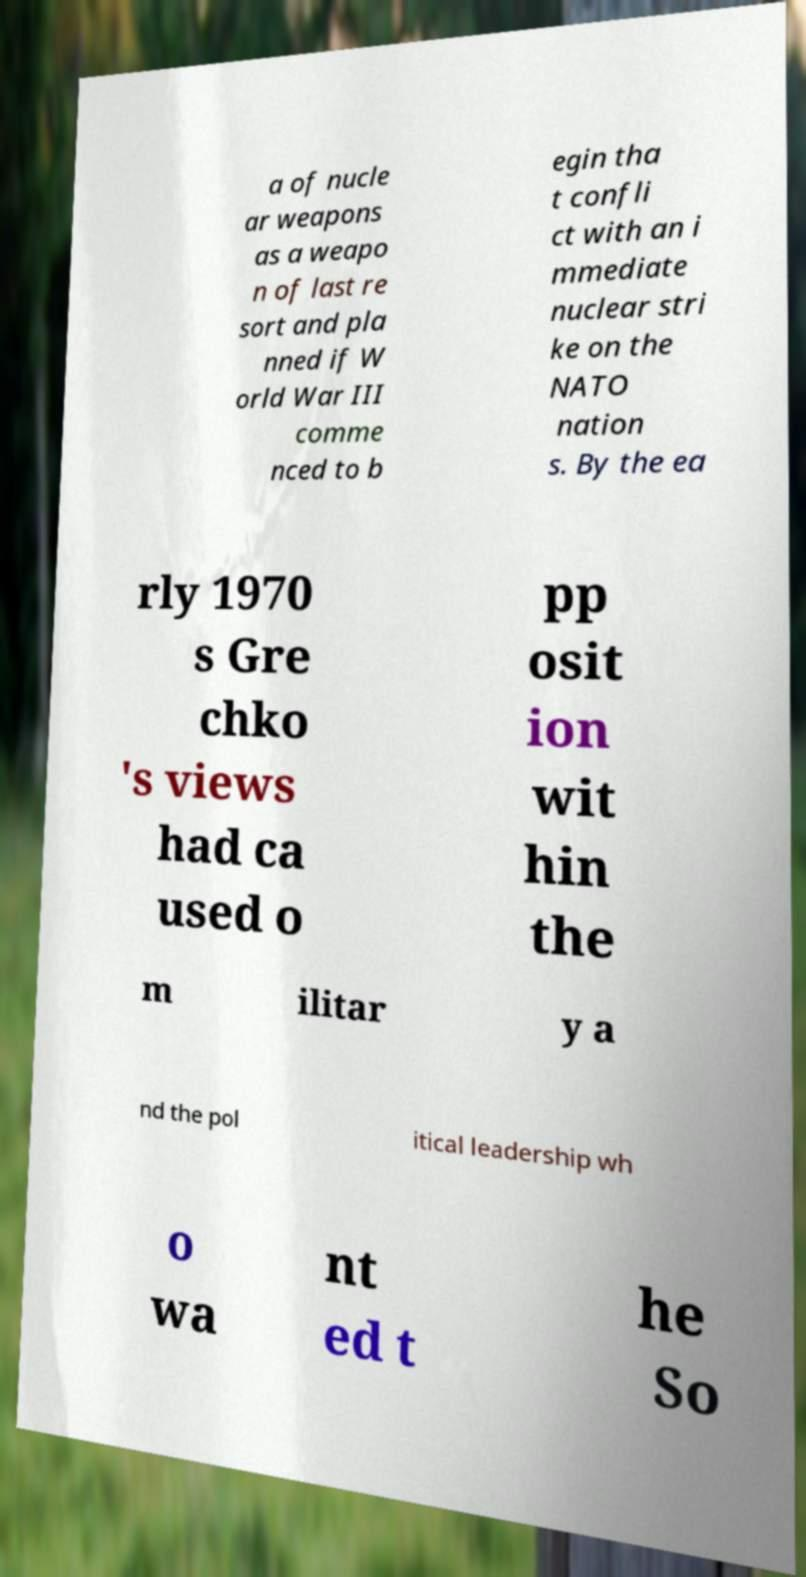Can you accurately transcribe the text from the provided image for me? a of nucle ar weapons as a weapo n of last re sort and pla nned if W orld War III comme nced to b egin tha t confli ct with an i mmediate nuclear stri ke on the NATO nation s. By the ea rly 1970 s Gre chko 's views had ca used o pp osit ion wit hin the m ilitar y a nd the pol itical leadership wh o wa nt ed t he So 